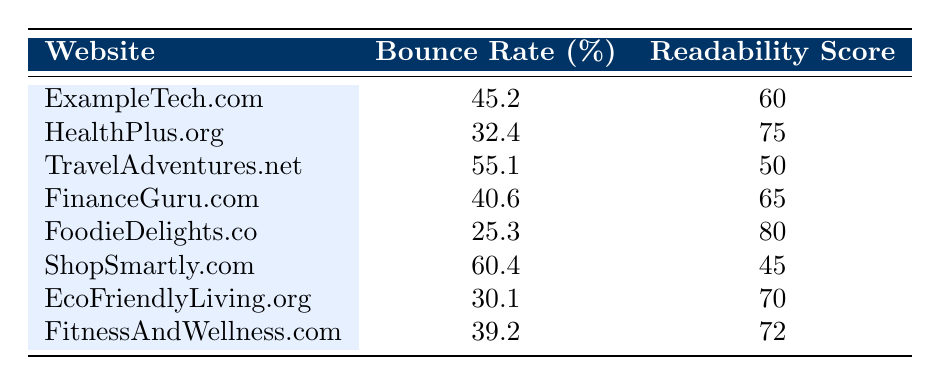What is the bounce rate for FoodieDelights.co? The table shows that the bounce rate for FoodieDelights.co is listed directly as 25.3.
Answer: 25.3 Which website has the highest readability score? By comparing the readability scores in the table, the highest score is 80 for FoodieDelights.co.
Answer: FoodieDelights.co What is the average bounce rate for all websites listed? To calculate the average bounce rate, sum all bounce rates: (45.2 + 32.4 + 55.1 + 40.6 + 25.3 + 60.4 + 30.1 + 39.2) = 328.3. Then divide by the number of websites (8): 328.3 / 8 = 41.04.
Answer: 41.04 Is the bounce rate of HealthPlus.org lower than that of EcoFriendlyLiving.org? The bounce rate for HealthPlus.org is 32.4, and for EcoFriendlyLiving.org, it is 30.1. Since 32.4 is greater than 30.1, the statement is false.
Answer: No Which website has a bounce rate above 50% and a readability score below 50? ShopSmartly.com has a bounce rate of 60.4 and a readability score of 45, which fits both criteria of being above 50% in bounce rate and below 50 in readability score.
Answer: ShopSmartly.com What is the total of the readability scores for websites with a bounce rate higher than 40%? The websites with bounce rates higher than 40% are ExampleTech.com (60), TravelAdventures.net (50), ShopSmartly.com (45), and FinanceGuru.com (65). Adding those scores gives: 60 + 50 + 45 + 65 = 220.
Answer: 220 Is the average readability score for websites with a bounce rate below 35% higher than that for those above 35%? First, identify the websites with a bounce rate below 35%: only FoodieDelights.co with a readability score of 80. For those above 35%, the average is calculated as follows: (60 + 75 + 50 + 65 + 45 + 70 + 72) / 7 = 61.43. Since 80 > 61.43, the statement is true.
Answer: Yes What percentage of the websites have a bounce rate that is 40% or more? The websites with a bounce rate of 40% or more are: ExampleTech.com (45.2), TravelAdventures.net (55.1), ShopSmartly.com (60.4), and FinanceGuru.com (40.6)—totaling 4 out of 8. Thus, (4/8) * 100 = 50%.
Answer: 50% 